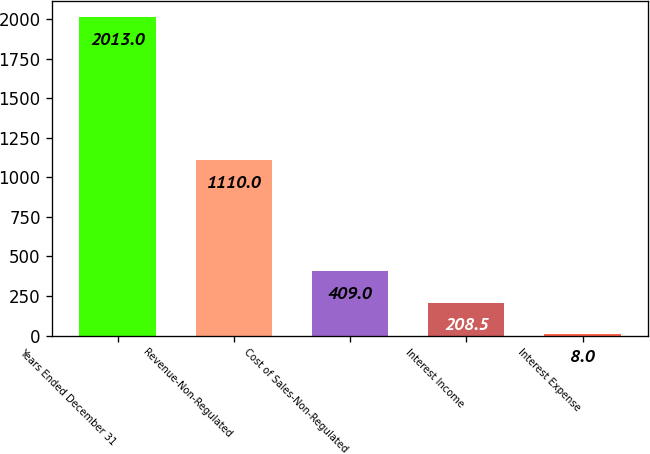Convert chart. <chart><loc_0><loc_0><loc_500><loc_500><bar_chart><fcel>Years Ended December 31<fcel>Revenue-Non-Regulated<fcel>Cost of Sales-Non-Regulated<fcel>Interest Income<fcel>Interest Expense<nl><fcel>2013<fcel>1110<fcel>409<fcel>208.5<fcel>8<nl></chart> 